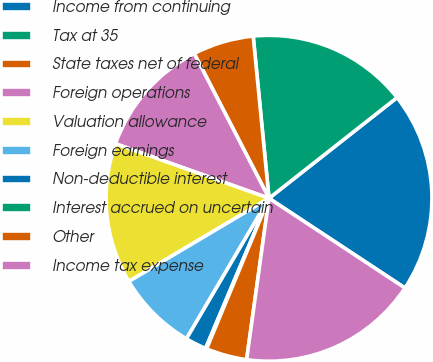Convert chart. <chart><loc_0><loc_0><loc_500><loc_500><pie_chart><fcel>Income from continuing<fcel>Tax at 35<fcel>State taxes net of federal<fcel>Foreign operations<fcel>Valuation allowance<fcel>Foreign earnings<fcel>Non-deductible interest<fcel>Interest accrued on uncertain<fcel>Other<fcel>Income tax expense<nl><fcel>19.89%<fcel>15.94%<fcel>6.04%<fcel>11.98%<fcel>13.96%<fcel>8.02%<fcel>2.09%<fcel>0.11%<fcel>4.06%<fcel>17.91%<nl></chart> 